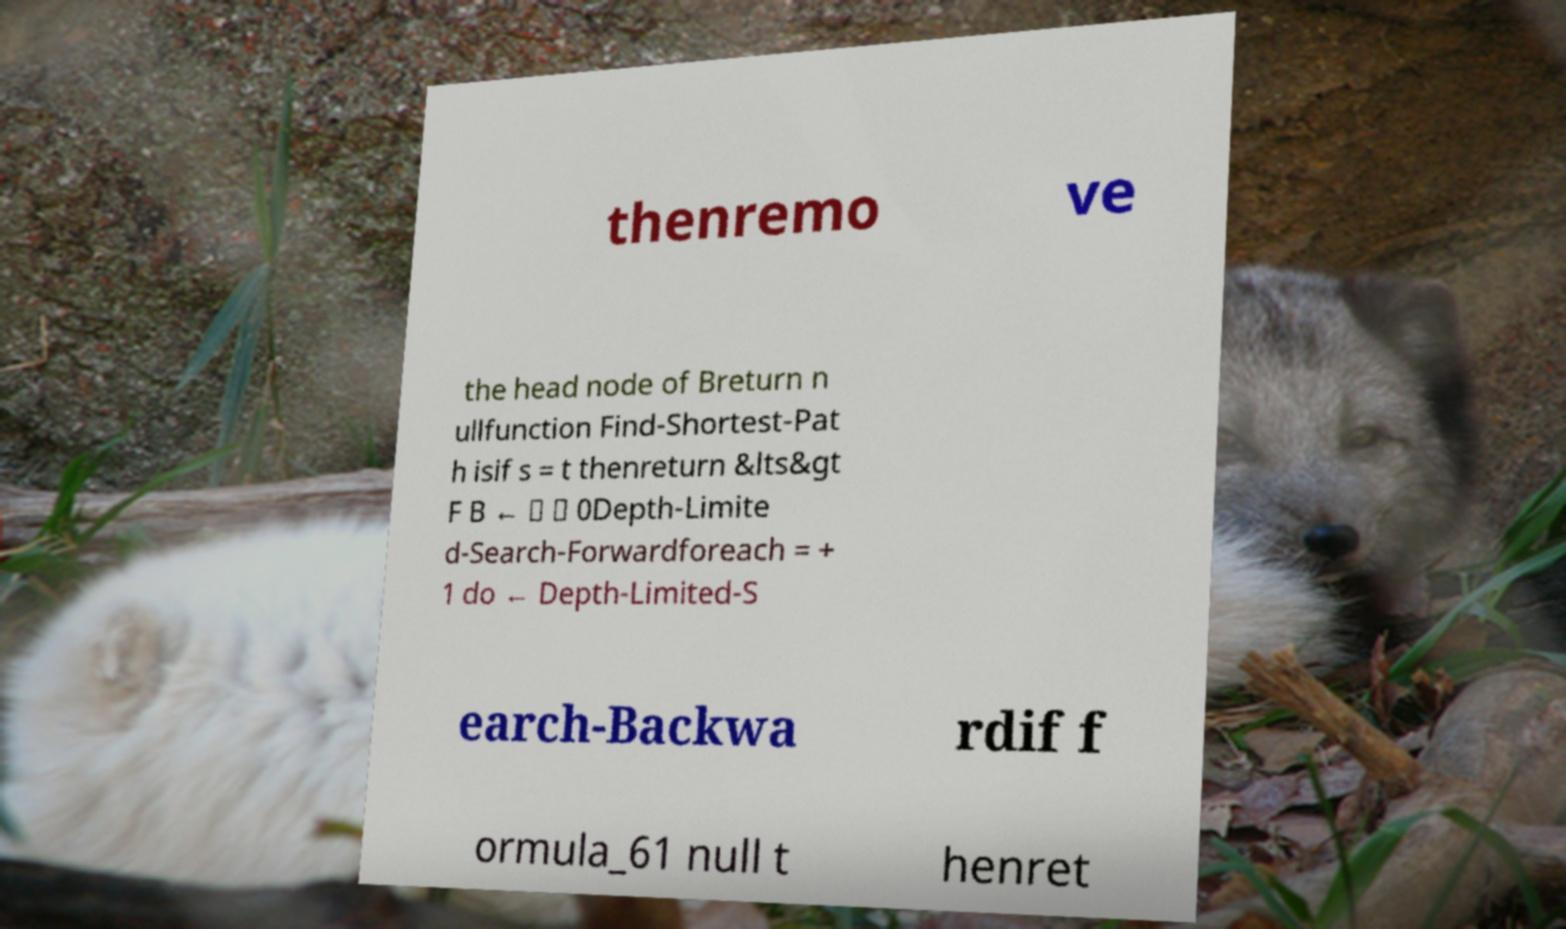Please read and relay the text visible in this image. What does it say? thenremo ve the head node of Breturn n ullfunction Find-Shortest-Pat h isif s = t thenreturn &lts&gt F B ← ∅ ∅ 0Depth-Limite d-Search-Forwardforeach = + 1 do ← Depth-Limited-S earch-Backwa rdif f ormula_61 null t henret 